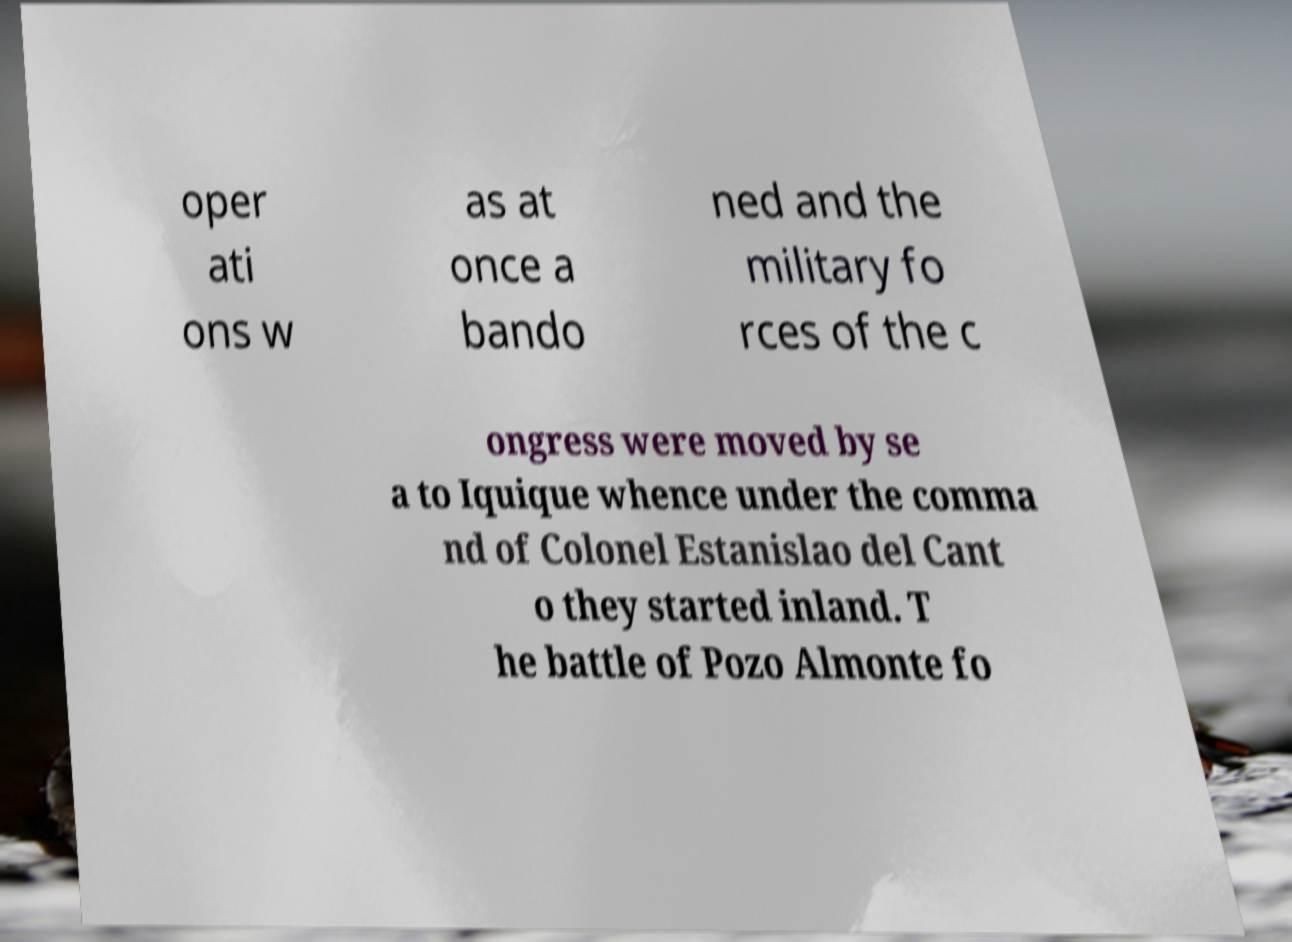Please identify and transcribe the text found in this image. oper ati ons w as at once a bando ned and the military fo rces of the c ongress were moved by se a to Iquique whence under the comma nd of Colonel Estanislao del Cant o they started inland. T he battle of Pozo Almonte fo 